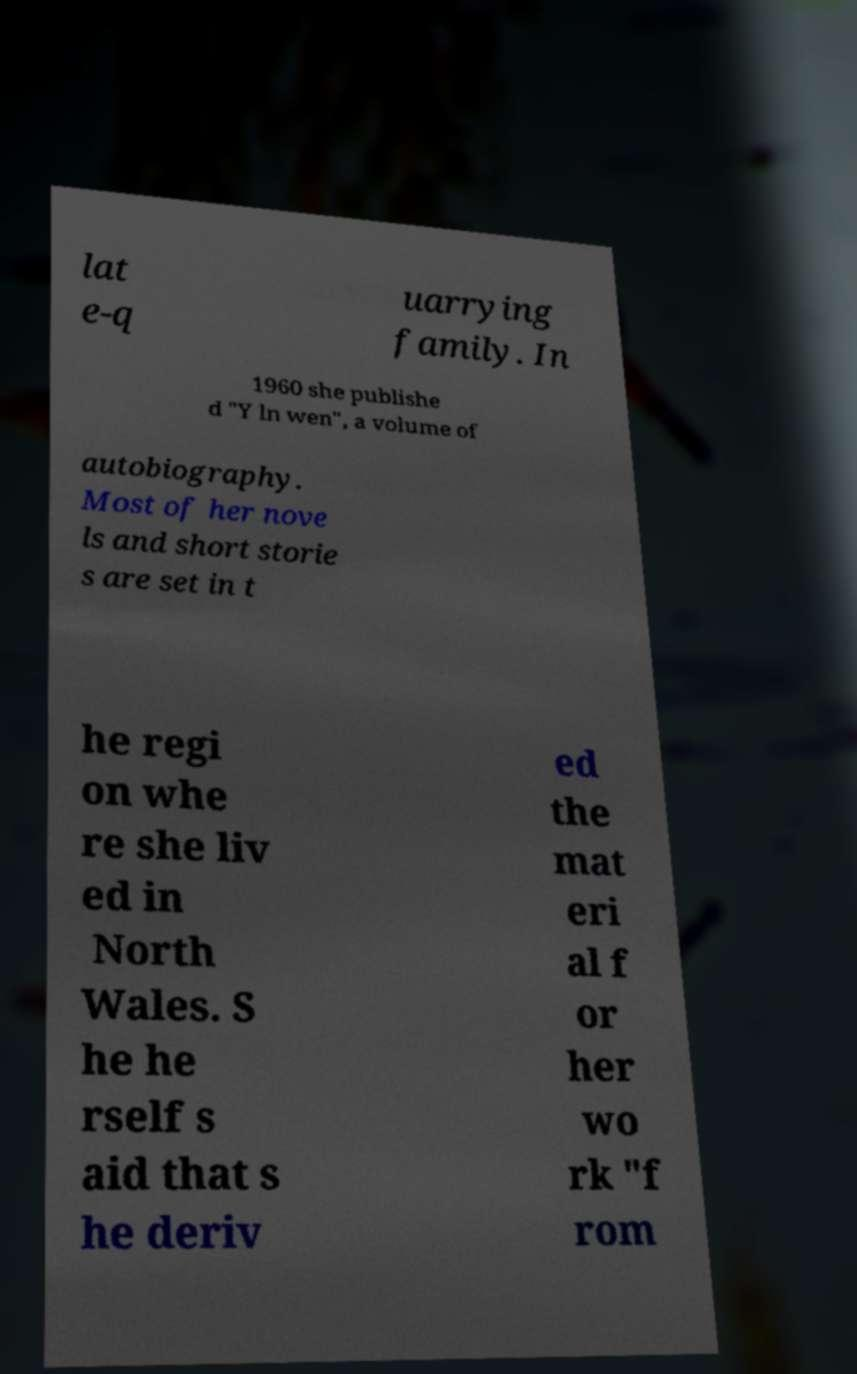Could you extract and type out the text from this image? lat e-q uarrying family. In 1960 she publishe d "Y ln wen", a volume of autobiography. Most of her nove ls and short storie s are set in t he regi on whe re she liv ed in North Wales. S he he rself s aid that s he deriv ed the mat eri al f or her wo rk "f rom 